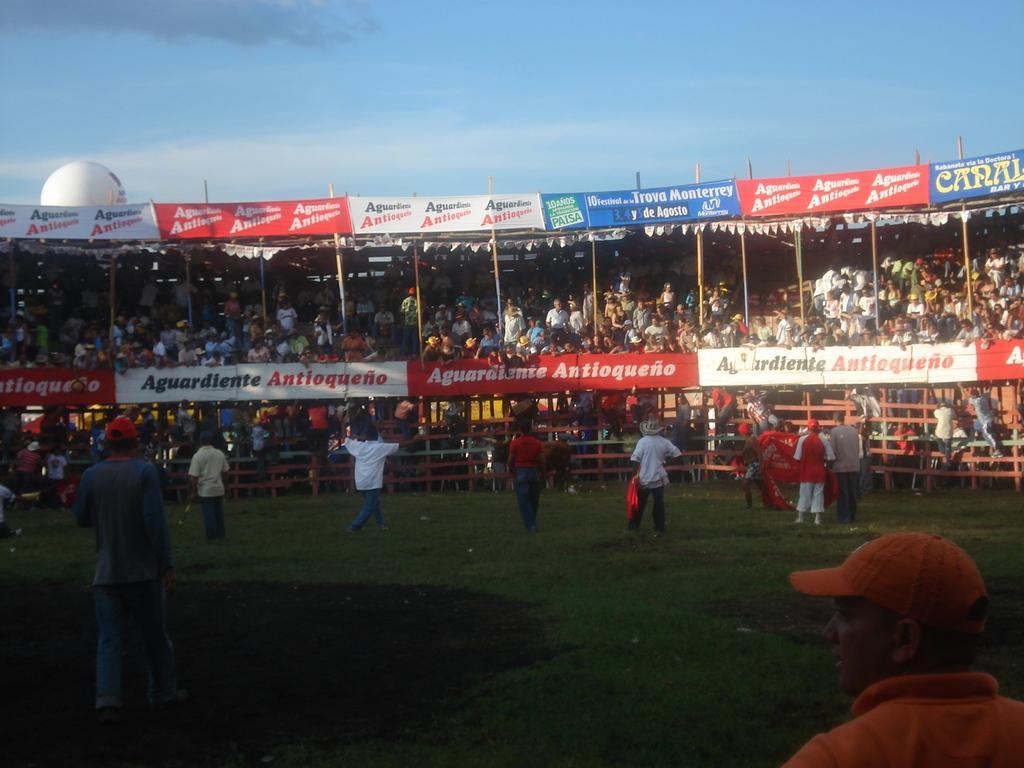Describe this image in one or two sentences. At the bottom of the image there is ground with few people are standing. And in the background there are many people sitting and also there are posters. At the top of the image there is a sky. 